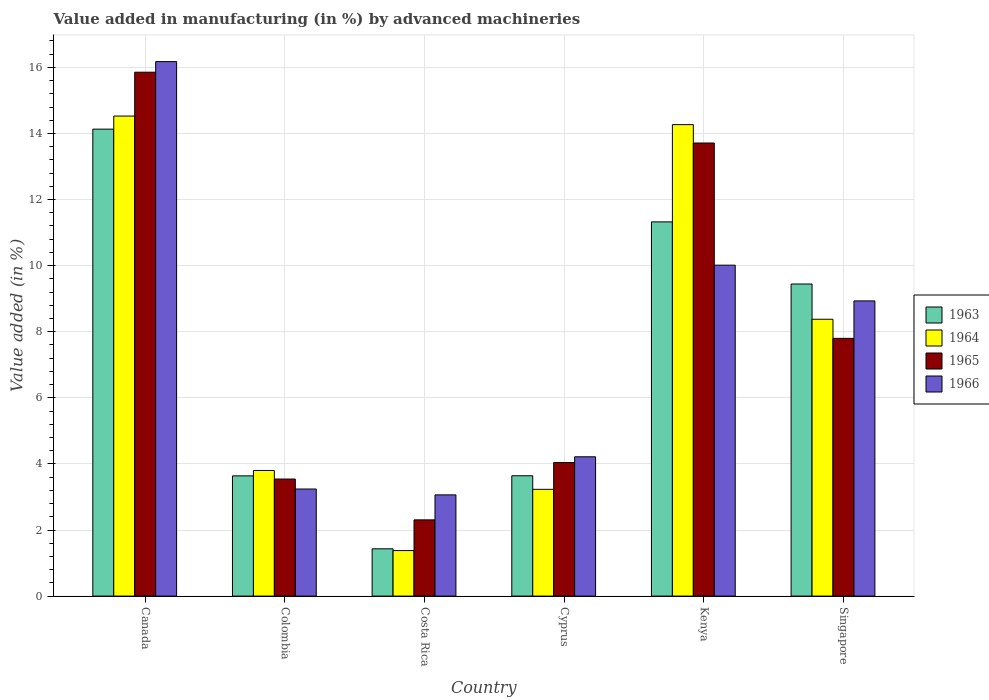How many different coloured bars are there?
Ensure brevity in your answer.  4. How many groups of bars are there?
Your answer should be compact. 6. Are the number of bars per tick equal to the number of legend labels?
Provide a succinct answer. Yes. Are the number of bars on each tick of the X-axis equal?
Offer a very short reply. Yes. How many bars are there on the 5th tick from the right?
Keep it short and to the point. 4. What is the label of the 4th group of bars from the left?
Ensure brevity in your answer.  Cyprus. In how many cases, is the number of bars for a given country not equal to the number of legend labels?
Your response must be concise. 0. What is the percentage of value added in manufacturing by advanced machineries in 1964 in Canada?
Make the answer very short. 14.53. Across all countries, what is the maximum percentage of value added in manufacturing by advanced machineries in 1966?
Your answer should be very brief. 16.17. Across all countries, what is the minimum percentage of value added in manufacturing by advanced machineries in 1965?
Give a very brief answer. 2.31. In which country was the percentage of value added in manufacturing by advanced machineries in 1963 maximum?
Make the answer very short. Canada. What is the total percentage of value added in manufacturing by advanced machineries in 1965 in the graph?
Your response must be concise. 47.25. What is the difference between the percentage of value added in manufacturing by advanced machineries in 1963 in Canada and that in Costa Rica?
Ensure brevity in your answer.  12.7. What is the difference between the percentage of value added in manufacturing by advanced machineries in 1964 in Singapore and the percentage of value added in manufacturing by advanced machineries in 1966 in Canada?
Your response must be concise. -7.8. What is the average percentage of value added in manufacturing by advanced machineries in 1966 per country?
Keep it short and to the point. 7.61. What is the difference between the percentage of value added in manufacturing by advanced machineries of/in 1964 and percentage of value added in manufacturing by advanced machineries of/in 1965 in Cyprus?
Your answer should be very brief. -0.81. What is the ratio of the percentage of value added in manufacturing by advanced machineries in 1964 in Costa Rica to that in Cyprus?
Provide a short and direct response. 0.43. Is the difference between the percentage of value added in manufacturing by advanced machineries in 1964 in Colombia and Cyprus greater than the difference between the percentage of value added in manufacturing by advanced machineries in 1965 in Colombia and Cyprus?
Offer a very short reply. Yes. What is the difference between the highest and the second highest percentage of value added in manufacturing by advanced machineries in 1966?
Your response must be concise. 7.24. What is the difference between the highest and the lowest percentage of value added in manufacturing by advanced machineries in 1965?
Your response must be concise. 13.55. In how many countries, is the percentage of value added in manufacturing by advanced machineries in 1966 greater than the average percentage of value added in manufacturing by advanced machineries in 1966 taken over all countries?
Keep it short and to the point. 3. Is the sum of the percentage of value added in manufacturing by advanced machineries in 1963 in Costa Rica and Cyprus greater than the maximum percentage of value added in manufacturing by advanced machineries in 1966 across all countries?
Offer a terse response. No. Is it the case that in every country, the sum of the percentage of value added in manufacturing by advanced machineries in 1963 and percentage of value added in manufacturing by advanced machineries in 1964 is greater than the sum of percentage of value added in manufacturing by advanced machineries in 1966 and percentage of value added in manufacturing by advanced machineries in 1965?
Provide a short and direct response. No. What does the 4th bar from the right in Singapore represents?
Ensure brevity in your answer.  1963. How many bars are there?
Your answer should be compact. 24. Are all the bars in the graph horizontal?
Make the answer very short. No. Does the graph contain any zero values?
Your answer should be compact. No. Where does the legend appear in the graph?
Offer a very short reply. Center right. How many legend labels are there?
Your response must be concise. 4. How are the legend labels stacked?
Your response must be concise. Vertical. What is the title of the graph?
Your response must be concise. Value added in manufacturing (in %) by advanced machineries. What is the label or title of the X-axis?
Your response must be concise. Country. What is the label or title of the Y-axis?
Give a very brief answer. Value added (in %). What is the Value added (in %) of 1963 in Canada?
Your answer should be compact. 14.13. What is the Value added (in %) of 1964 in Canada?
Make the answer very short. 14.53. What is the Value added (in %) of 1965 in Canada?
Keep it short and to the point. 15.85. What is the Value added (in %) in 1966 in Canada?
Ensure brevity in your answer.  16.17. What is the Value added (in %) in 1963 in Colombia?
Provide a short and direct response. 3.64. What is the Value added (in %) of 1964 in Colombia?
Provide a short and direct response. 3.8. What is the Value added (in %) of 1965 in Colombia?
Make the answer very short. 3.54. What is the Value added (in %) in 1966 in Colombia?
Provide a succinct answer. 3.24. What is the Value added (in %) in 1963 in Costa Rica?
Offer a very short reply. 1.43. What is the Value added (in %) of 1964 in Costa Rica?
Your answer should be very brief. 1.38. What is the Value added (in %) in 1965 in Costa Rica?
Your answer should be compact. 2.31. What is the Value added (in %) in 1966 in Costa Rica?
Offer a very short reply. 3.06. What is the Value added (in %) in 1963 in Cyprus?
Provide a succinct answer. 3.64. What is the Value added (in %) in 1964 in Cyprus?
Make the answer very short. 3.23. What is the Value added (in %) in 1965 in Cyprus?
Your answer should be compact. 4.04. What is the Value added (in %) in 1966 in Cyprus?
Provide a succinct answer. 4.22. What is the Value added (in %) in 1963 in Kenya?
Ensure brevity in your answer.  11.32. What is the Value added (in %) of 1964 in Kenya?
Offer a terse response. 14.27. What is the Value added (in %) in 1965 in Kenya?
Keep it short and to the point. 13.71. What is the Value added (in %) in 1966 in Kenya?
Keep it short and to the point. 10.01. What is the Value added (in %) of 1963 in Singapore?
Ensure brevity in your answer.  9.44. What is the Value added (in %) of 1964 in Singapore?
Offer a terse response. 8.38. What is the Value added (in %) in 1965 in Singapore?
Give a very brief answer. 7.8. What is the Value added (in %) in 1966 in Singapore?
Ensure brevity in your answer.  8.93. Across all countries, what is the maximum Value added (in %) in 1963?
Ensure brevity in your answer.  14.13. Across all countries, what is the maximum Value added (in %) of 1964?
Your response must be concise. 14.53. Across all countries, what is the maximum Value added (in %) in 1965?
Make the answer very short. 15.85. Across all countries, what is the maximum Value added (in %) in 1966?
Your answer should be compact. 16.17. Across all countries, what is the minimum Value added (in %) of 1963?
Make the answer very short. 1.43. Across all countries, what is the minimum Value added (in %) in 1964?
Your answer should be very brief. 1.38. Across all countries, what is the minimum Value added (in %) of 1965?
Offer a very short reply. 2.31. Across all countries, what is the minimum Value added (in %) of 1966?
Provide a succinct answer. 3.06. What is the total Value added (in %) of 1963 in the graph?
Offer a terse response. 43.61. What is the total Value added (in %) in 1964 in the graph?
Offer a very short reply. 45.58. What is the total Value added (in %) in 1965 in the graph?
Make the answer very short. 47.25. What is the total Value added (in %) in 1966 in the graph?
Provide a succinct answer. 45.64. What is the difference between the Value added (in %) in 1963 in Canada and that in Colombia?
Provide a short and direct response. 10.49. What is the difference between the Value added (in %) of 1964 in Canada and that in Colombia?
Your answer should be very brief. 10.72. What is the difference between the Value added (in %) of 1965 in Canada and that in Colombia?
Your response must be concise. 12.31. What is the difference between the Value added (in %) of 1966 in Canada and that in Colombia?
Your answer should be very brief. 12.93. What is the difference between the Value added (in %) in 1963 in Canada and that in Costa Rica?
Keep it short and to the point. 12.7. What is the difference between the Value added (in %) in 1964 in Canada and that in Costa Rica?
Provide a succinct answer. 13.15. What is the difference between the Value added (in %) of 1965 in Canada and that in Costa Rica?
Your answer should be very brief. 13.55. What is the difference between the Value added (in %) of 1966 in Canada and that in Costa Rica?
Your answer should be compact. 13.11. What is the difference between the Value added (in %) of 1963 in Canada and that in Cyprus?
Ensure brevity in your answer.  10.49. What is the difference between the Value added (in %) in 1964 in Canada and that in Cyprus?
Ensure brevity in your answer.  11.3. What is the difference between the Value added (in %) of 1965 in Canada and that in Cyprus?
Offer a very short reply. 11.81. What is the difference between the Value added (in %) in 1966 in Canada and that in Cyprus?
Ensure brevity in your answer.  11.96. What is the difference between the Value added (in %) of 1963 in Canada and that in Kenya?
Offer a very short reply. 2.81. What is the difference between the Value added (in %) in 1964 in Canada and that in Kenya?
Your answer should be compact. 0.26. What is the difference between the Value added (in %) in 1965 in Canada and that in Kenya?
Provide a short and direct response. 2.14. What is the difference between the Value added (in %) of 1966 in Canada and that in Kenya?
Ensure brevity in your answer.  6.16. What is the difference between the Value added (in %) of 1963 in Canada and that in Singapore?
Give a very brief answer. 4.69. What is the difference between the Value added (in %) in 1964 in Canada and that in Singapore?
Provide a succinct answer. 6.15. What is the difference between the Value added (in %) of 1965 in Canada and that in Singapore?
Ensure brevity in your answer.  8.05. What is the difference between the Value added (in %) in 1966 in Canada and that in Singapore?
Offer a terse response. 7.24. What is the difference between the Value added (in %) of 1963 in Colombia and that in Costa Rica?
Offer a very short reply. 2.21. What is the difference between the Value added (in %) in 1964 in Colombia and that in Costa Rica?
Keep it short and to the point. 2.42. What is the difference between the Value added (in %) of 1965 in Colombia and that in Costa Rica?
Your response must be concise. 1.24. What is the difference between the Value added (in %) in 1966 in Colombia and that in Costa Rica?
Your answer should be very brief. 0.18. What is the difference between the Value added (in %) in 1963 in Colombia and that in Cyprus?
Provide a short and direct response. -0. What is the difference between the Value added (in %) in 1964 in Colombia and that in Cyprus?
Make the answer very short. 0.57. What is the difference between the Value added (in %) of 1965 in Colombia and that in Cyprus?
Make the answer very short. -0.5. What is the difference between the Value added (in %) in 1966 in Colombia and that in Cyprus?
Provide a short and direct response. -0.97. What is the difference between the Value added (in %) in 1963 in Colombia and that in Kenya?
Provide a succinct answer. -7.69. What is the difference between the Value added (in %) in 1964 in Colombia and that in Kenya?
Offer a terse response. -10.47. What is the difference between the Value added (in %) of 1965 in Colombia and that in Kenya?
Offer a very short reply. -10.17. What is the difference between the Value added (in %) of 1966 in Colombia and that in Kenya?
Provide a short and direct response. -6.77. What is the difference between the Value added (in %) of 1963 in Colombia and that in Singapore?
Your answer should be very brief. -5.81. What is the difference between the Value added (in %) in 1964 in Colombia and that in Singapore?
Your answer should be very brief. -4.58. What is the difference between the Value added (in %) in 1965 in Colombia and that in Singapore?
Keep it short and to the point. -4.26. What is the difference between the Value added (in %) in 1966 in Colombia and that in Singapore?
Provide a succinct answer. -5.69. What is the difference between the Value added (in %) of 1963 in Costa Rica and that in Cyprus?
Make the answer very short. -2.21. What is the difference between the Value added (in %) in 1964 in Costa Rica and that in Cyprus?
Provide a short and direct response. -1.85. What is the difference between the Value added (in %) of 1965 in Costa Rica and that in Cyprus?
Provide a short and direct response. -1.73. What is the difference between the Value added (in %) in 1966 in Costa Rica and that in Cyprus?
Your answer should be compact. -1.15. What is the difference between the Value added (in %) in 1963 in Costa Rica and that in Kenya?
Offer a terse response. -9.89. What is the difference between the Value added (in %) in 1964 in Costa Rica and that in Kenya?
Your answer should be very brief. -12.89. What is the difference between the Value added (in %) of 1965 in Costa Rica and that in Kenya?
Keep it short and to the point. -11.4. What is the difference between the Value added (in %) of 1966 in Costa Rica and that in Kenya?
Ensure brevity in your answer.  -6.95. What is the difference between the Value added (in %) in 1963 in Costa Rica and that in Singapore?
Make the answer very short. -8.01. What is the difference between the Value added (in %) of 1964 in Costa Rica and that in Singapore?
Offer a very short reply. -7. What is the difference between the Value added (in %) in 1965 in Costa Rica and that in Singapore?
Offer a terse response. -5.49. What is the difference between the Value added (in %) of 1966 in Costa Rica and that in Singapore?
Your response must be concise. -5.87. What is the difference between the Value added (in %) of 1963 in Cyprus and that in Kenya?
Make the answer very short. -7.68. What is the difference between the Value added (in %) in 1964 in Cyprus and that in Kenya?
Keep it short and to the point. -11.04. What is the difference between the Value added (in %) in 1965 in Cyprus and that in Kenya?
Your answer should be very brief. -9.67. What is the difference between the Value added (in %) in 1966 in Cyprus and that in Kenya?
Offer a very short reply. -5.8. What is the difference between the Value added (in %) in 1963 in Cyprus and that in Singapore?
Your answer should be very brief. -5.8. What is the difference between the Value added (in %) in 1964 in Cyprus and that in Singapore?
Offer a very short reply. -5.15. What is the difference between the Value added (in %) in 1965 in Cyprus and that in Singapore?
Keep it short and to the point. -3.76. What is the difference between the Value added (in %) in 1966 in Cyprus and that in Singapore?
Make the answer very short. -4.72. What is the difference between the Value added (in %) in 1963 in Kenya and that in Singapore?
Your response must be concise. 1.88. What is the difference between the Value added (in %) in 1964 in Kenya and that in Singapore?
Give a very brief answer. 5.89. What is the difference between the Value added (in %) of 1965 in Kenya and that in Singapore?
Give a very brief answer. 5.91. What is the difference between the Value added (in %) in 1966 in Kenya and that in Singapore?
Provide a succinct answer. 1.08. What is the difference between the Value added (in %) in 1963 in Canada and the Value added (in %) in 1964 in Colombia?
Make the answer very short. 10.33. What is the difference between the Value added (in %) in 1963 in Canada and the Value added (in %) in 1965 in Colombia?
Your response must be concise. 10.59. What is the difference between the Value added (in %) in 1963 in Canada and the Value added (in %) in 1966 in Colombia?
Offer a very short reply. 10.89. What is the difference between the Value added (in %) of 1964 in Canada and the Value added (in %) of 1965 in Colombia?
Provide a succinct answer. 10.98. What is the difference between the Value added (in %) of 1964 in Canada and the Value added (in %) of 1966 in Colombia?
Offer a terse response. 11.29. What is the difference between the Value added (in %) in 1965 in Canada and the Value added (in %) in 1966 in Colombia?
Ensure brevity in your answer.  12.61. What is the difference between the Value added (in %) in 1963 in Canada and the Value added (in %) in 1964 in Costa Rica?
Offer a very short reply. 12.75. What is the difference between the Value added (in %) in 1963 in Canada and the Value added (in %) in 1965 in Costa Rica?
Provide a succinct answer. 11.82. What is the difference between the Value added (in %) in 1963 in Canada and the Value added (in %) in 1966 in Costa Rica?
Ensure brevity in your answer.  11.07. What is the difference between the Value added (in %) of 1964 in Canada and the Value added (in %) of 1965 in Costa Rica?
Provide a short and direct response. 12.22. What is the difference between the Value added (in %) in 1964 in Canada and the Value added (in %) in 1966 in Costa Rica?
Provide a short and direct response. 11.46. What is the difference between the Value added (in %) of 1965 in Canada and the Value added (in %) of 1966 in Costa Rica?
Your answer should be very brief. 12.79. What is the difference between the Value added (in %) of 1963 in Canada and the Value added (in %) of 1964 in Cyprus?
Provide a succinct answer. 10.9. What is the difference between the Value added (in %) of 1963 in Canada and the Value added (in %) of 1965 in Cyprus?
Ensure brevity in your answer.  10.09. What is the difference between the Value added (in %) in 1963 in Canada and the Value added (in %) in 1966 in Cyprus?
Provide a short and direct response. 9.92. What is the difference between the Value added (in %) of 1964 in Canada and the Value added (in %) of 1965 in Cyprus?
Ensure brevity in your answer.  10.49. What is the difference between the Value added (in %) in 1964 in Canada and the Value added (in %) in 1966 in Cyprus?
Your answer should be very brief. 10.31. What is the difference between the Value added (in %) in 1965 in Canada and the Value added (in %) in 1966 in Cyprus?
Offer a very short reply. 11.64. What is the difference between the Value added (in %) of 1963 in Canada and the Value added (in %) of 1964 in Kenya?
Your response must be concise. -0.14. What is the difference between the Value added (in %) in 1963 in Canada and the Value added (in %) in 1965 in Kenya?
Ensure brevity in your answer.  0.42. What is the difference between the Value added (in %) in 1963 in Canada and the Value added (in %) in 1966 in Kenya?
Ensure brevity in your answer.  4.12. What is the difference between the Value added (in %) of 1964 in Canada and the Value added (in %) of 1965 in Kenya?
Your answer should be very brief. 0.82. What is the difference between the Value added (in %) of 1964 in Canada and the Value added (in %) of 1966 in Kenya?
Make the answer very short. 4.51. What is the difference between the Value added (in %) of 1965 in Canada and the Value added (in %) of 1966 in Kenya?
Provide a succinct answer. 5.84. What is the difference between the Value added (in %) in 1963 in Canada and the Value added (in %) in 1964 in Singapore?
Ensure brevity in your answer.  5.75. What is the difference between the Value added (in %) in 1963 in Canada and the Value added (in %) in 1965 in Singapore?
Provide a succinct answer. 6.33. What is the difference between the Value added (in %) in 1963 in Canada and the Value added (in %) in 1966 in Singapore?
Your answer should be very brief. 5.2. What is the difference between the Value added (in %) in 1964 in Canada and the Value added (in %) in 1965 in Singapore?
Offer a terse response. 6.73. What is the difference between the Value added (in %) in 1964 in Canada and the Value added (in %) in 1966 in Singapore?
Your response must be concise. 5.59. What is the difference between the Value added (in %) of 1965 in Canada and the Value added (in %) of 1966 in Singapore?
Ensure brevity in your answer.  6.92. What is the difference between the Value added (in %) in 1963 in Colombia and the Value added (in %) in 1964 in Costa Rica?
Your answer should be compact. 2.26. What is the difference between the Value added (in %) in 1963 in Colombia and the Value added (in %) in 1965 in Costa Rica?
Provide a succinct answer. 1.33. What is the difference between the Value added (in %) in 1963 in Colombia and the Value added (in %) in 1966 in Costa Rica?
Provide a succinct answer. 0.57. What is the difference between the Value added (in %) in 1964 in Colombia and the Value added (in %) in 1965 in Costa Rica?
Offer a very short reply. 1.49. What is the difference between the Value added (in %) in 1964 in Colombia and the Value added (in %) in 1966 in Costa Rica?
Keep it short and to the point. 0.74. What is the difference between the Value added (in %) in 1965 in Colombia and the Value added (in %) in 1966 in Costa Rica?
Your answer should be very brief. 0.48. What is the difference between the Value added (in %) of 1963 in Colombia and the Value added (in %) of 1964 in Cyprus?
Keep it short and to the point. 0.41. What is the difference between the Value added (in %) of 1963 in Colombia and the Value added (in %) of 1965 in Cyprus?
Ensure brevity in your answer.  -0.4. What is the difference between the Value added (in %) in 1963 in Colombia and the Value added (in %) in 1966 in Cyprus?
Ensure brevity in your answer.  -0.58. What is the difference between the Value added (in %) in 1964 in Colombia and the Value added (in %) in 1965 in Cyprus?
Your response must be concise. -0.24. What is the difference between the Value added (in %) of 1964 in Colombia and the Value added (in %) of 1966 in Cyprus?
Ensure brevity in your answer.  -0.41. What is the difference between the Value added (in %) in 1965 in Colombia and the Value added (in %) in 1966 in Cyprus?
Your answer should be very brief. -0.67. What is the difference between the Value added (in %) of 1963 in Colombia and the Value added (in %) of 1964 in Kenya?
Offer a terse response. -10.63. What is the difference between the Value added (in %) of 1963 in Colombia and the Value added (in %) of 1965 in Kenya?
Provide a succinct answer. -10.07. What is the difference between the Value added (in %) of 1963 in Colombia and the Value added (in %) of 1966 in Kenya?
Your response must be concise. -6.38. What is the difference between the Value added (in %) in 1964 in Colombia and the Value added (in %) in 1965 in Kenya?
Provide a short and direct response. -9.91. What is the difference between the Value added (in %) in 1964 in Colombia and the Value added (in %) in 1966 in Kenya?
Make the answer very short. -6.21. What is the difference between the Value added (in %) in 1965 in Colombia and the Value added (in %) in 1966 in Kenya?
Your answer should be compact. -6.47. What is the difference between the Value added (in %) in 1963 in Colombia and the Value added (in %) in 1964 in Singapore?
Your answer should be compact. -4.74. What is the difference between the Value added (in %) of 1963 in Colombia and the Value added (in %) of 1965 in Singapore?
Keep it short and to the point. -4.16. What is the difference between the Value added (in %) in 1963 in Colombia and the Value added (in %) in 1966 in Singapore?
Offer a terse response. -5.29. What is the difference between the Value added (in %) in 1964 in Colombia and the Value added (in %) in 1965 in Singapore?
Offer a very short reply. -4. What is the difference between the Value added (in %) in 1964 in Colombia and the Value added (in %) in 1966 in Singapore?
Your answer should be very brief. -5.13. What is the difference between the Value added (in %) in 1965 in Colombia and the Value added (in %) in 1966 in Singapore?
Your answer should be very brief. -5.39. What is the difference between the Value added (in %) of 1963 in Costa Rica and the Value added (in %) of 1964 in Cyprus?
Offer a terse response. -1.8. What is the difference between the Value added (in %) of 1963 in Costa Rica and the Value added (in %) of 1965 in Cyprus?
Provide a short and direct response. -2.61. What is the difference between the Value added (in %) in 1963 in Costa Rica and the Value added (in %) in 1966 in Cyprus?
Make the answer very short. -2.78. What is the difference between the Value added (in %) in 1964 in Costa Rica and the Value added (in %) in 1965 in Cyprus?
Your answer should be compact. -2.66. What is the difference between the Value added (in %) of 1964 in Costa Rica and the Value added (in %) of 1966 in Cyprus?
Ensure brevity in your answer.  -2.84. What is the difference between the Value added (in %) of 1965 in Costa Rica and the Value added (in %) of 1966 in Cyprus?
Offer a terse response. -1.91. What is the difference between the Value added (in %) of 1963 in Costa Rica and the Value added (in %) of 1964 in Kenya?
Give a very brief answer. -12.84. What is the difference between the Value added (in %) of 1963 in Costa Rica and the Value added (in %) of 1965 in Kenya?
Your response must be concise. -12.28. What is the difference between the Value added (in %) in 1963 in Costa Rica and the Value added (in %) in 1966 in Kenya?
Provide a short and direct response. -8.58. What is the difference between the Value added (in %) of 1964 in Costa Rica and the Value added (in %) of 1965 in Kenya?
Offer a terse response. -12.33. What is the difference between the Value added (in %) in 1964 in Costa Rica and the Value added (in %) in 1966 in Kenya?
Offer a terse response. -8.64. What is the difference between the Value added (in %) in 1965 in Costa Rica and the Value added (in %) in 1966 in Kenya?
Make the answer very short. -7.71. What is the difference between the Value added (in %) of 1963 in Costa Rica and the Value added (in %) of 1964 in Singapore?
Your answer should be compact. -6.95. What is the difference between the Value added (in %) in 1963 in Costa Rica and the Value added (in %) in 1965 in Singapore?
Your response must be concise. -6.37. What is the difference between the Value added (in %) of 1963 in Costa Rica and the Value added (in %) of 1966 in Singapore?
Your answer should be compact. -7.5. What is the difference between the Value added (in %) in 1964 in Costa Rica and the Value added (in %) in 1965 in Singapore?
Offer a terse response. -6.42. What is the difference between the Value added (in %) of 1964 in Costa Rica and the Value added (in %) of 1966 in Singapore?
Your response must be concise. -7.55. What is the difference between the Value added (in %) of 1965 in Costa Rica and the Value added (in %) of 1966 in Singapore?
Your answer should be compact. -6.63. What is the difference between the Value added (in %) of 1963 in Cyprus and the Value added (in %) of 1964 in Kenya?
Give a very brief answer. -10.63. What is the difference between the Value added (in %) in 1963 in Cyprus and the Value added (in %) in 1965 in Kenya?
Ensure brevity in your answer.  -10.07. What is the difference between the Value added (in %) of 1963 in Cyprus and the Value added (in %) of 1966 in Kenya?
Ensure brevity in your answer.  -6.37. What is the difference between the Value added (in %) of 1964 in Cyprus and the Value added (in %) of 1965 in Kenya?
Keep it short and to the point. -10.48. What is the difference between the Value added (in %) in 1964 in Cyprus and the Value added (in %) in 1966 in Kenya?
Ensure brevity in your answer.  -6.78. What is the difference between the Value added (in %) of 1965 in Cyprus and the Value added (in %) of 1966 in Kenya?
Provide a short and direct response. -5.97. What is the difference between the Value added (in %) in 1963 in Cyprus and the Value added (in %) in 1964 in Singapore?
Make the answer very short. -4.74. What is the difference between the Value added (in %) in 1963 in Cyprus and the Value added (in %) in 1965 in Singapore?
Offer a very short reply. -4.16. What is the difference between the Value added (in %) of 1963 in Cyprus and the Value added (in %) of 1966 in Singapore?
Provide a short and direct response. -5.29. What is the difference between the Value added (in %) of 1964 in Cyprus and the Value added (in %) of 1965 in Singapore?
Your answer should be compact. -4.57. What is the difference between the Value added (in %) in 1964 in Cyprus and the Value added (in %) in 1966 in Singapore?
Provide a succinct answer. -5.7. What is the difference between the Value added (in %) of 1965 in Cyprus and the Value added (in %) of 1966 in Singapore?
Your answer should be very brief. -4.89. What is the difference between the Value added (in %) in 1963 in Kenya and the Value added (in %) in 1964 in Singapore?
Your answer should be compact. 2.95. What is the difference between the Value added (in %) in 1963 in Kenya and the Value added (in %) in 1965 in Singapore?
Give a very brief answer. 3.52. What is the difference between the Value added (in %) of 1963 in Kenya and the Value added (in %) of 1966 in Singapore?
Keep it short and to the point. 2.39. What is the difference between the Value added (in %) in 1964 in Kenya and the Value added (in %) in 1965 in Singapore?
Your response must be concise. 6.47. What is the difference between the Value added (in %) of 1964 in Kenya and the Value added (in %) of 1966 in Singapore?
Make the answer very short. 5.33. What is the difference between the Value added (in %) of 1965 in Kenya and the Value added (in %) of 1966 in Singapore?
Offer a terse response. 4.78. What is the average Value added (in %) in 1963 per country?
Make the answer very short. 7.27. What is the average Value added (in %) in 1964 per country?
Your answer should be very brief. 7.6. What is the average Value added (in %) in 1965 per country?
Provide a succinct answer. 7.88. What is the average Value added (in %) of 1966 per country?
Give a very brief answer. 7.61. What is the difference between the Value added (in %) of 1963 and Value added (in %) of 1964 in Canada?
Your answer should be compact. -0.4. What is the difference between the Value added (in %) in 1963 and Value added (in %) in 1965 in Canada?
Your answer should be compact. -1.72. What is the difference between the Value added (in %) of 1963 and Value added (in %) of 1966 in Canada?
Your response must be concise. -2.04. What is the difference between the Value added (in %) in 1964 and Value added (in %) in 1965 in Canada?
Keep it short and to the point. -1.33. What is the difference between the Value added (in %) in 1964 and Value added (in %) in 1966 in Canada?
Ensure brevity in your answer.  -1.65. What is the difference between the Value added (in %) in 1965 and Value added (in %) in 1966 in Canada?
Offer a terse response. -0.32. What is the difference between the Value added (in %) of 1963 and Value added (in %) of 1964 in Colombia?
Provide a short and direct response. -0.16. What is the difference between the Value added (in %) in 1963 and Value added (in %) in 1965 in Colombia?
Offer a terse response. 0.1. What is the difference between the Value added (in %) in 1963 and Value added (in %) in 1966 in Colombia?
Ensure brevity in your answer.  0.4. What is the difference between the Value added (in %) in 1964 and Value added (in %) in 1965 in Colombia?
Ensure brevity in your answer.  0.26. What is the difference between the Value added (in %) in 1964 and Value added (in %) in 1966 in Colombia?
Offer a very short reply. 0.56. What is the difference between the Value added (in %) of 1965 and Value added (in %) of 1966 in Colombia?
Provide a succinct answer. 0.3. What is the difference between the Value added (in %) of 1963 and Value added (in %) of 1964 in Costa Rica?
Your answer should be compact. 0.05. What is the difference between the Value added (in %) of 1963 and Value added (in %) of 1965 in Costa Rica?
Offer a very short reply. -0.88. What is the difference between the Value added (in %) in 1963 and Value added (in %) in 1966 in Costa Rica?
Keep it short and to the point. -1.63. What is the difference between the Value added (in %) in 1964 and Value added (in %) in 1965 in Costa Rica?
Provide a short and direct response. -0.93. What is the difference between the Value added (in %) in 1964 and Value added (in %) in 1966 in Costa Rica?
Your answer should be compact. -1.69. What is the difference between the Value added (in %) of 1965 and Value added (in %) of 1966 in Costa Rica?
Provide a succinct answer. -0.76. What is the difference between the Value added (in %) in 1963 and Value added (in %) in 1964 in Cyprus?
Provide a short and direct response. 0.41. What is the difference between the Value added (in %) of 1963 and Value added (in %) of 1965 in Cyprus?
Offer a terse response. -0.4. What is the difference between the Value added (in %) of 1963 and Value added (in %) of 1966 in Cyprus?
Provide a succinct answer. -0.57. What is the difference between the Value added (in %) of 1964 and Value added (in %) of 1965 in Cyprus?
Provide a short and direct response. -0.81. What is the difference between the Value added (in %) of 1964 and Value added (in %) of 1966 in Cyprus?
Make the answer very short. -0.98. What is the difference between the Value added (in %) of 1965 and Value added (in %) of 1966 in Cyprus?
Ensure brevity in your answer.  -0.17. What is the difference between the Value added (in %) of 1963 and Value added (in %) of 1964 in Kenya?
Your answer should be very brief. -2.94. What is the difference between the Value added (in %) of 1963 and Value added (in %) of 1965 in Kenya?
Make the answer very short. -2.39. What is the difference between the Value added (in %) in 1963 and Value added (in %) in 1966 in Kenya?
Your answer should be very brief. 1.31. What is the difference between the Value added (in %) of 1964 and Value added (in %) of 1965 in Kenya?
Ensure brevity in your answer.  0.56. What is the difference between the Value added (in %) in 1964 and Value added (in %) in 1966 in Kenya?
Offer a terse response. 4.25. What is the difference between the Value added (in %) in 1965 and Value added (in %) in 1966 in Kenya?
Provide a succinct answer. 3.7. What is the difference between the Value added (in %) in 1963 and Value added (in %) in 1964 in Singapore?
Your answer should be compact. 1.07. What is the difference between the Value added (in %) in 1963 and Value added (in %) in 1965 in Singapore?
Offer a very short reply. 1.64. What is the difference between the Value added (in %) in 1963 and Value added (in %) in 1966 in Singapore?
Offer a terse response. 0.51. What is the difference between the Value added (in %) of 1964 and Value added (in %) of 1965 in Singapore?
Your answer should be compact. 0.58. What is the difference between the Value added (in %) in 1964 and Value added (in %) in 1966 in Singapore?
Keep it short and to the point. -0.55. What is the difference between the Value added (in %) in 1965 and Value added (in %) in 1966 in Singapore?
Ensure brevity in your answer.  -1.13. What is the ratio of the Value added (in %) of 1963 in Canada to that in Colombia?
Give a very brief answer. 3.88. What is the ratio of the Value added (in %) of 1964 in Canada to that in Colombia?
Your response must be concise. 3.82. What is the ratio of the Value added (in %) of 1965 in Canada to that in Colombia?
Your response must be concise. 4.48. What is the ratio of the Value added (in %) of 1966 in Canada to that in Colombia?
Make the answer very short. 4.99. What is the ratio of the Value added (in %) of 1963 in Canada to that in Costa Rica?
Offer a very short reply. 9.87. What is the ratio of the Value added (in %) in 1964 in Canada to that in Costa Rica?
Provide a succinct answer. 10.54. What is the ratio of the Value added (in %) of 1965 in Canada to that in Costa Rica?
Your answer should be compact. 6.87. What is the ratio of the Value added (in %) in 1966 in Canada to that in Costa Rica?
Provide a succinct answer. 5.28. What is the ratio of the Value added (in %) of 1963 in Canada to that in Cyprus?
Give a very brief answer. 3.88. What is the ratio of the Value added (in %) in 1964 in Canada to that in Cyprus?
Give a very brief answer. 4.5. What is the ratio of the Value added (in %) in 1965 in Canada to that in Cyprus?
Your answer should be very brief. 3.92. What is the ratio of the Value added (in %) of 1966 in Canada to that in Cyprus?
Your response must be concise. 3.84. What is the ratio of the Value added (in %) of 1963 in Canada to that in Kenya?
Give a very brief answer. 1.25. What is the ratio of the Value added (in %) of 1964 in Canada to that in Kenya?
Provide a short and direct response. 1.02. What is the ratio of the Value added (in %) in 1965 in Canada to that in Kenya?
Provide a short and direct response. 1.16. What is the ratio of the Value added (in %) of 1966 in Canada to that in Kenya?
Ensure brevity in your answer.  1.62. What is the ratio of the Value added (in %) of 1963 in Canada to that in Singapore?
Offer a very short reply. 1.5. What is the ratio of the Value added (in %) of 1964 in Canada to that in Singapore?
Provide a succinct answer. 1.73. What is the ratio of the Value added (in %) in 1965 in Canada to that in Singapore?
Ensure brevity in your answer.  2.03. What is the ratio of the Value added (in %) in 1966 in Canada to that in Singapore?
Give a very brief answer. 1.81. What is the ratio of the Value added (in %) of 1963 in Colombia to that in Costa Rica?
Ensure brevity in your answer.  2.54. What is the ratio of the Value added (in %) of 1964 in Colombia to that in Costa Rica?
Ensure brevity in your answer.  2.76. What is the ratio of the Value added (in %) of 1965 in Colombia to that in Costa Rica?
Your response must be concise. 1.54. What is the ratio of the Value added (in %) of 1966 in Colombia to that in Costa Rica?
Ensure brevity in your answer.  1.06. What is the ratio of the Value added (in %) in 1964 in Colombia to that in Cyprus?
Your answer should be compact. 1.18. What is the ratio of the Value added (in %) of 1965 in Colombia to that in Cyprus?
Provide a short and direct response. 0.88. What is the ratio of the Value added (in %) of 1966 in Colombia to that in Cyprus?
Ensure brevity in your answer.  0.77. What is the ratio of the Value added (in %) in 1963 in Colombia to that in Kenya?
Give a very brief answer. 0.32. What is the ratio of the Value added (in %) of 1964 in Colombia to that in Kenya?
Your answer should be very brief. 0.27. What is the ratio of the Value added (in %) of 1965 in Colombia to that in Kenya?
Provide a short and direct response. 0.26. What is the ratio of the Value added (in %) of 1966 in Colombia to that in Kenya?
Your answer should be very brief. 0.32. What is the ratio of the Value added (in %) of 1963 in Colombia to that in Singapore?
Your response must be concise. 0.39. What is the ratio of the Value added (in %) of 1964 in Colombia to that in Singapore?
Ensure brevity in your answer.  0.45. What is the ratio of the Value added (in %) of 1965 in Colombia to that in Singapore?
Provide a succinct answer. 0.45. What is the ratio of the Value added (in %) in 1966 in Colombia to that in Singapore?
Ensure brevity in your answer.  0.36. What is the ratio of the Value added (in %) in 1963 in Costa Rica to that in Cyprus?
Keep it short and to the point. 0.39. What is the ratio of the Value added (in %) in 1964 in Costa Rica to that in Cyprus?
Your answer should be compact. 0.43. What is the ratio of the Value added (in %) in 1965 in Costa Rica to that in Cyprus?
Ensure brevity in your answer.  0.57. What is the ratio of the Value added (in %) of 1966 in Costa Rica to that in Cyprus?
Provide a short and direct response. 0.73. What is the ratio of the Value added (in %) of 1963 in Costa Rica to that in Kenya?
Your answer should be very brief. 0.13. What is the ratio of the Value added (in %) of 1964 in Costa Rica to that in Kenya?
Offer a terse response. 0.1. What is the ratio of the Value added (in %) of 1965 in Costa Rica to that in Kenya?
Keep it short and to the point. 0.17. What is the ratio of the Value added (in %) of 1966 in Costa Rica to that in Kenya?
Ensure brevity in your answer.  0.31. What is the ratio of the Value added (in %) of 1963 in Costa Rica to that in Singapore?
Offer a terse response. 0.15. What is the ratio of the Value added (in %) in 1964 in Costa Rica to that in Singapore?
Provide a short and direct response. 0.16. What is the ratio of the Value added (in %) in 1965 in Costa Rica to that in Singapore?
Provide a short and direct response. 0.3. What is the ratio of the Value added (in %) of 1966 in Costa Rica to that in Singapore?
Your answer should be very brief. 0.34. What is the ratio of the Value added (in %) of 1963 in Cyprus to that in Kenya?
Offer a very short reply. 0.32. What is the ratio of the Value added (in %) in 1964 in Cyprus to that in Kenya?
Ensure brevity in your answer.  0.23. What is the ratio of the Value added (in %) of 1965 in Cyprus to that in Kenya?
Offer a very short reply. 0.29. What is the ratio of the Value added (in %) in 1966 in Cyprus to that in Kenya?
Provide a short and direct response. 0.42. What is the ratio of the Value added (in %) in 1963 in Cyprus to that in Singapore?
Offer a terse response. 0.39. What is the ratio of the Value added (in %) in 1964 in Cyprus to that in Singapore?
Offer a very short reply. 0.39. What is the ratio of the Value added (in %) of 1965 in Cyprus to that in Singapore?
Give a very brief answer. 0.52. What is the ratio of the Value added (in %) of 1966 in Cyprus to that in Singapore?
Offer a very short reply. 0.47. What is the ratio of the Value added (in %) in 1963 in Kenya to that in Singapore?
Keep it short and to the point. 1.2. What is the ratio of the Value added (in %) of 1964 in Kenya to that in Singapore?
Ensure brevity in your answer.  1.7. What is the ratio of the Value added (in %) in 1965 in Kenya to that in Singapore?
Ensure brevity in your answer.  1.76. What is the ratio of the Value added (in %) in 1966 in Kenya to that in Singapore?
Your answer should be compact. 1.12. What is the difference between the highest and the second highest Value added (in %) in 1963?
Provide a short and direct response. 2.81. What is the difference between the highest and the second highest Value added (in %) of 1964?
Provide a succinct answer. 0.26. What is the difference between the highest and the second highest Value added (in %) in 1965?
Make the answer very short. 2.14. What is the difference between the highest and the second highest Value added (in %) in 1966?
Ensure brevity in your answer.  6.16. What is the difference between the highest and the lowest Value added (in %) of 1963?
Provide a succinct answer. 12.7. What is the difference between the highest and the lowest Value added (in %) in 1964?
Ensure brevity in your answer.  13.15. What is the difference between the highest and the lowest Value added (in %) in 1965?
Offer a very short reply. 13.55. What is the difference between the highest and the lowest Value added (in %) in 1966?
Give a very brief answer. 13.11. 